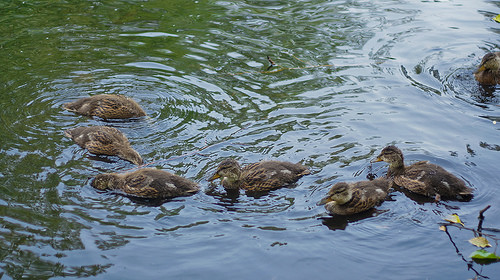<image>
Is the duck in the lake? Yes. The duck is contained within or inside the lake, showing a containment relationship. 